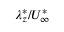<formula> <loc_0><loc_0><loc_500><loc_500>\lambda _ { z } ^ { \ast } / U _ { \infty } ^ { \ast }</formula> 